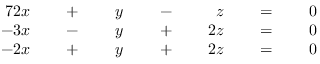Convert formula to latex. <formula><loc_0><loc_0><loc_500><loc_500>{ \begin{array} { r l r l r l r l r l r l r } { { 7 } 2 x } & { \, + \, } & { y } & { \, - \, } & { z } & { \, = \, } & { 0 } \\ { - 3 x } & { \, - \, } & { y } & { \, + \, } & { 2 z } & { \, = \, } & { 0 } \\ { - 2 x } & { \, + \, } & { y } & { \, + \, } & { 2 z } & { \, = \, } & { 0 } \end{array} }</formula> 